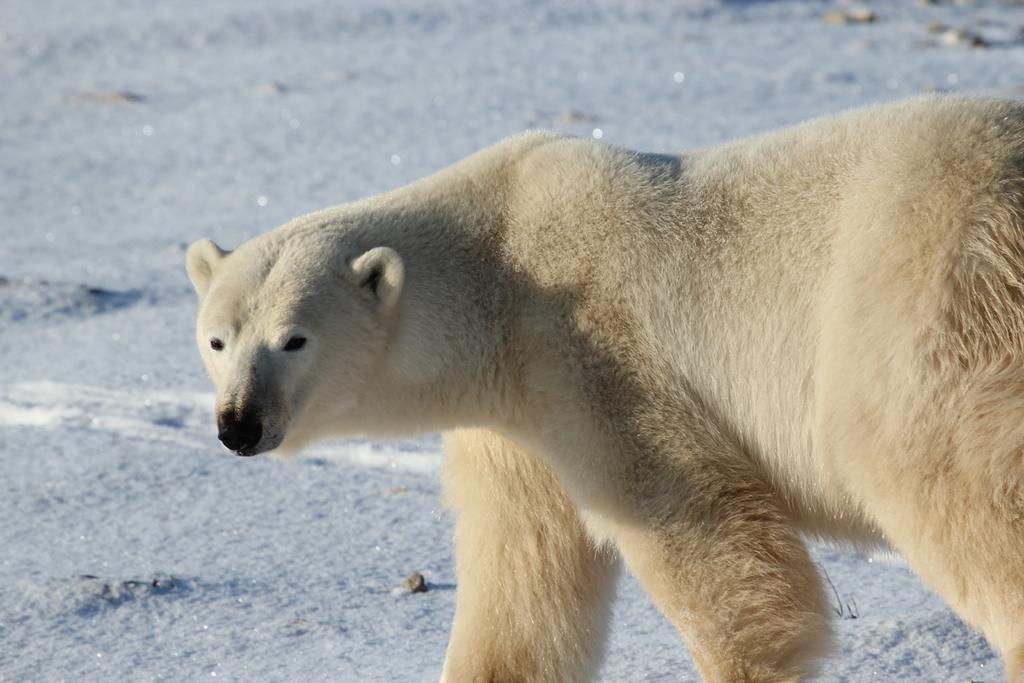Could you give a brief overview of what you see in this image? As we can see in the image in the front there is a cream color polar bear. 